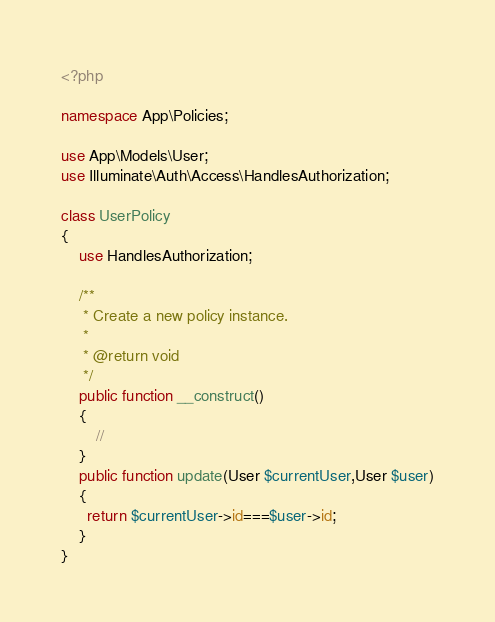Convert code to text. <code><loc_0><loc_0><loc_500><loc_500><_PHP_><?php

namespace App\Policies;

use App\Models\User;
use Illuminate\Auth\Access\HandlesAuthorization;

class UserPolicy
{
    use HandlesAuthorization;

    /**
     * Create a new policy instance.
     *
     * @return void
     */
    public function __construct()
    {
        //
    }
    public function update(User $currentUser,User $user)
    {
      return $currentUser->id===$user->id;
    }
}
</code> 